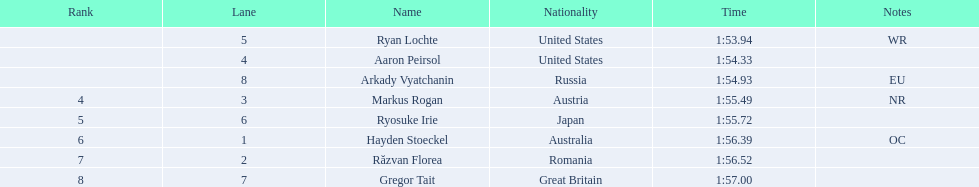What is the name of the contestant in lane 6? Ryosuke Irie. How long did it take that player to complete the race? 1:55.72. 